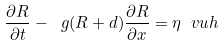Convert formula to latex. <formula><loc_0><loc_0><loc_500><loc_500>\frac { \partial R } { \partial t } - \ g ( R + d ) \frac { \partial R } { \partial x } = \eta \ v u h</formula> 